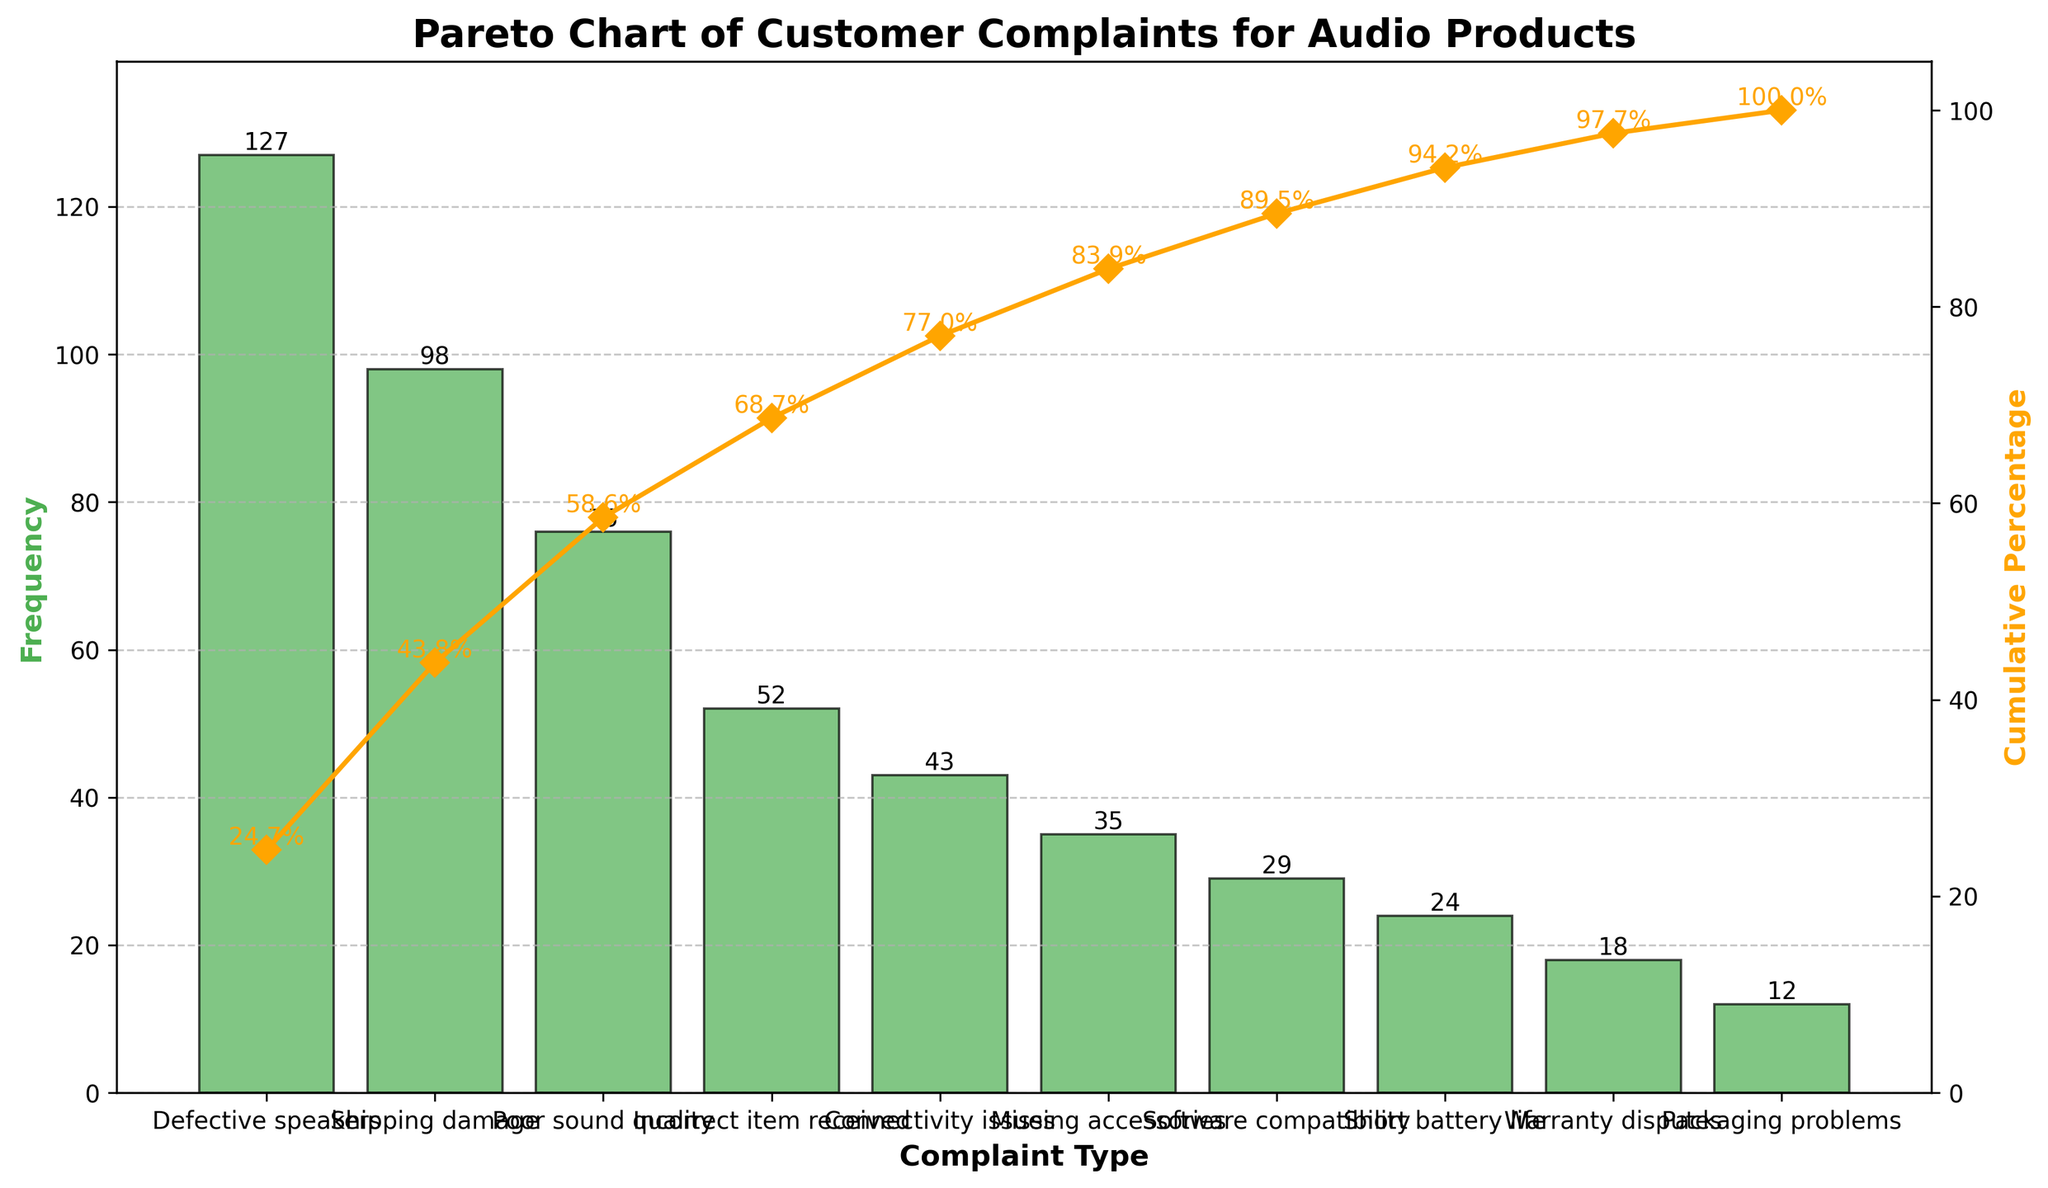What is the most frequent customer complaint type? The Pareto chart shows the frequency of different complaint types. The highest bar represents "Defective speakers" with a frequency of 127.
Answer: Defective speakers Which complaint type has the least frequency? The lowest bar on the Pareto chart represents "Packaging problems" with a frequency of 12.
Answer: Packaging problems How many types of customer complaints are shown in the chart? Count the number of distinct complaint types listed along the x-axis. There are 10 distinct types.
Answer: 10 What is the cumulative percentage for "Poor sound quality"? Locate the point on the Pareto chart where "Poor sound quality" is listed and check the cumulative percentage line directly above it. The cumulative percentage is approximately 66.7%.
Answer: 66.7% Which complaint type is associated with the cumulative percentage crossing 80%? Find the points on the cumulative percentage line until it crosses 80%, which occurs after "Connectivity issues".
Answer: Connectivity issues What is the total number of complaints analyzed? Sum the frequencies of all listed complaint types. 127 + 98 + 76 + 52 + 43 + 35 + 29 + 24 + 18 + 12 = 514.
Answer: 514 By how much does the frequency of "Shipping damage" complaints exceed "Software compatibility" complaints? Subtract the frequency of "Software compatibility" (29) from "Shipping damage" (98). 98 - 29 = 69.
Answer: 69 What percentage of the complaints are attributed to the top three complaint types? The top three complaint types are "Defective speakers" (127), "Shipping damage" (98), and "Poor sound quality" (76). Sum their frequencies and divide by the total, then multiply by 100. (127 + 98 + 76) / 514 * 100 ≈ 58.4%.
Answer: 58.4% How many complaint types together account for at least 50% of the total complaints? Sum the frequencies until reaching or exceeding 50% of the total. The cumulative sum of the first three complaint types ("Defective speakers", "Shipping damage", "Poor sound quality") is 127 + 98 + 76 = 301. 301 / 514 * 100 ≈ 58.4%, which crosses 50%. Thus, 3 types account for at least 50%.
Answer: 3 Which complaint has a frequency between 20 and 30? Identify complaint types with frequencies within this range. "Short battery life" has a frequency of 24 and falls between 20 and 30.
Answer: Short battery life 